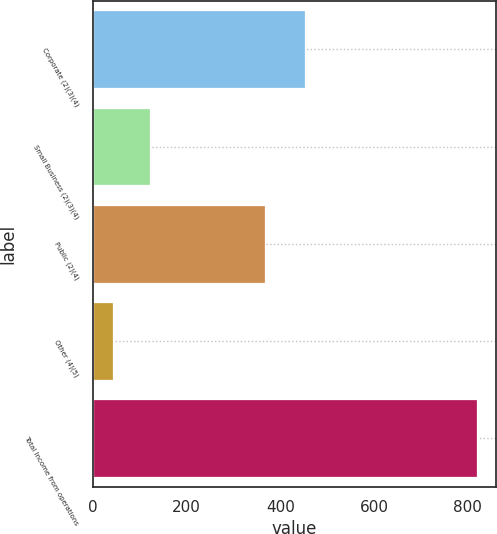Convert chart to OTSL. <chart><loc_0><loc_0><loc_500><loc_500><bar_chart><fcel>Corporate (2)(3)(4)<fcel>Small Business (2)(3)(4)<fcel>Public (2)(4)<fcel>Other (4)(5)<fcel>Total Income from operations<nl><fcel>453.6<fcel>121.16<fcel>368<fcel>43.6<fcel>819.2<nl></chart> 